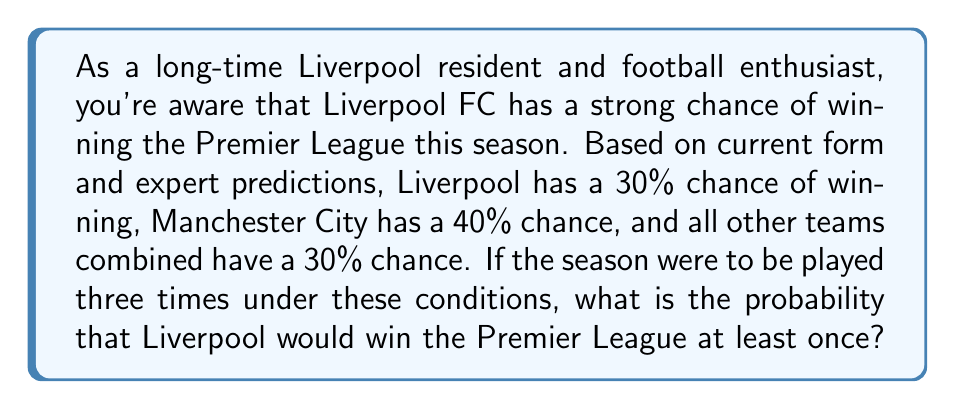Can you answer this question? Let's approach this step-by-step:

1) First, we need to calculate the probability of Liverpool not winning in a single season:
   $P(\text{Liverpool not winning}) = 1 - P(\text{Liverpool winning}) = 1 - 0.30 = 0.70$

2) Now, for Liverpool to not win in all three seasons, this needs to happen three times in a row. The probability of this is:
   $P(\text{Liverpool not winning in 3 seasons}) = 0.70 \times 0.70 \times 0.70 = 0.70^3 = 0.343$

3) Therefore, the probability of Liverpool winning at least once in three seasons is the opposite of not winning at all:
   $P(\text{Liverpool winning at least once}) = 1 - P(\text{Liverpool not winning in 3 seasons})$
   $= 1 - 0.343 = 0.657$

4) We can also calculate this using the binomial probability formula:
   $$P(X \geq 1) = 1 - P(X = 0) = 1 - \binom{3}{0}(0.30)^0(0.70)^3 = 0.657$$

   Where $X$ is the number of times Liverpool wins in 3 seasons.
Answer: The probability that Liverpool FC would win the Premier League at least once if the season were played three times under these conditions is approximately 0.657 or 65.7%. 